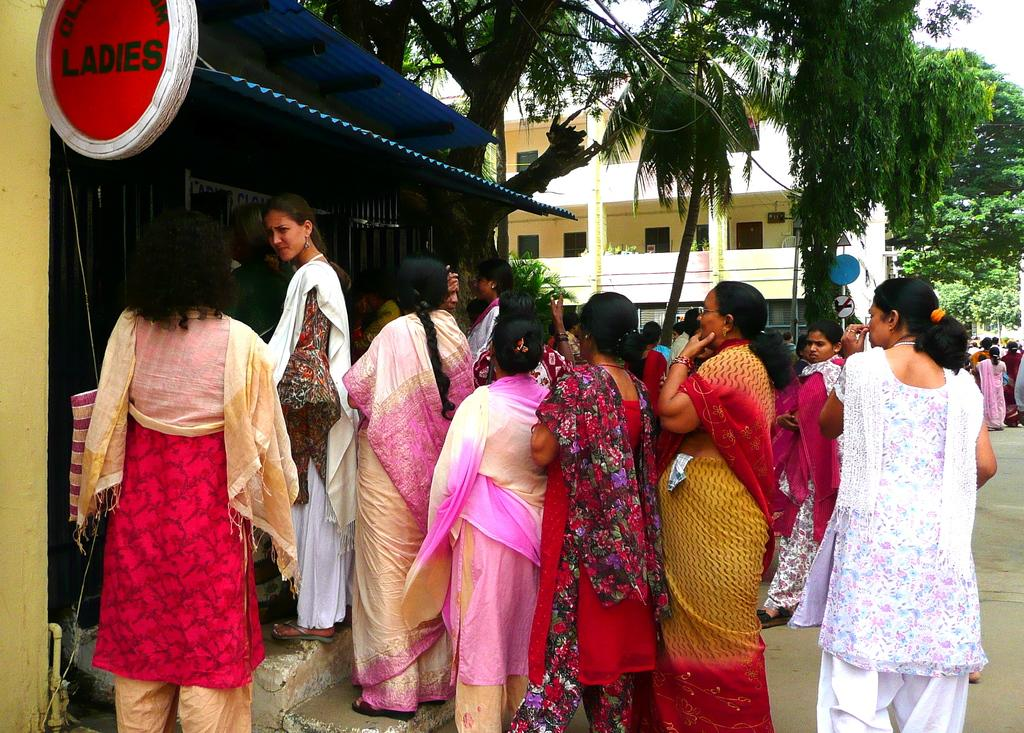What can be seen in the image involving people? There are people standing in the image. What are the people wearing? The people are wearing clothes. What is the board with text used for in the image? The board with text might be used for communication or displaying information. What type of surface can be seen in the image? There is a road visible in the image. What type of natural elements are present in the image? There are trees in the image. What type of man-made structure is present in the image? There is a building in the image. What part of the natural environment is visible in the image? The sky is visible in the image. How many eyes can be seen on the camp in the image? There is no camp present in the image, and therefore no eyes can be seen on it. What type of system is being used to organize the people in the image? There is no system mentioned or depicted for organizing the people in the image; they are simply standing. 